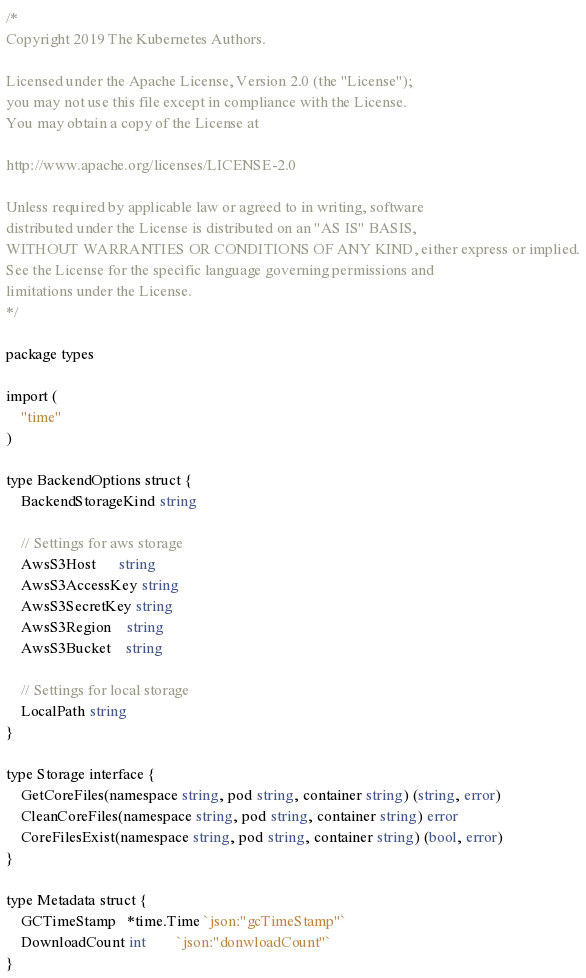Convert code to text. <code><loc_0><loc_0><loc_500><loc_500><_Go_>/*
Copyright 2019 The Kubernetes Authors.

Licensed under the Apache License, Version 2.0 (the "License");
you may not use this file except in compliance with the License.
You may obtain a copy of the License at

http://www.apache.org/licenses/LICENSE-2.0

Unless required by applicable law or agreed to in writing, software
distributed under the License is distributed on an "AS IS" BASIS,
WITHOUT WARRANTIES OR CONDITIONS OF ANY KIND, either express or implied.
See the License for the specific language governing permissions and
limitations under the License.
*/

package types

import (
	"time"
)

type BackendOptions struct {
	BackendStorageKind string

	// Settings for aws storage
	AwsS3Host      string
	AwsS3AccessKey string
	AwsS3SecretKey string
	AwsS3Region    string
	AwsS3Bucket    string

	// Settings for local storage
	LocalPath string
}

type Storage interface {
	GetCoreFiles(namespace string, pod string, container string) (string, error)
	CleanCoreFiles(namespace string, pod string, container string) error
	CoreFilesExist(namespace string, pod string, container string) (bool, error)
}

type Metadata struct {
	GCTimeStamp   *time.Time `json:"gcTimeStamp"`
	DownloadCount int        `json:"donwloadCount"`
}
</code> 